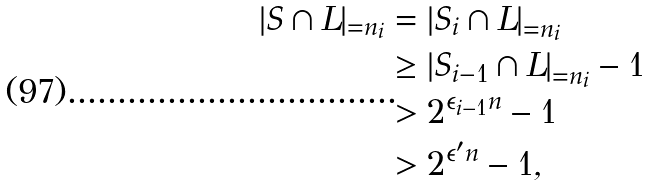Convert formula to latex. <formula><loc_0><loc_0><loc_500><loc_500>| S \cap L | _ { = n _ { i } } & = \left | S _ { i } \cap L \right | _ { = n _ { i } } \\ & \geq \left | S _ { i - 1 } \cap L \right | _ { = n _ { i } } - 1 \\ & > 2 ^ { \epsilon _ { i - 1 } n } - 1 \\ & > 2 ^ { \epsilon ^ { \prime } n } - 1 ,</formula> 